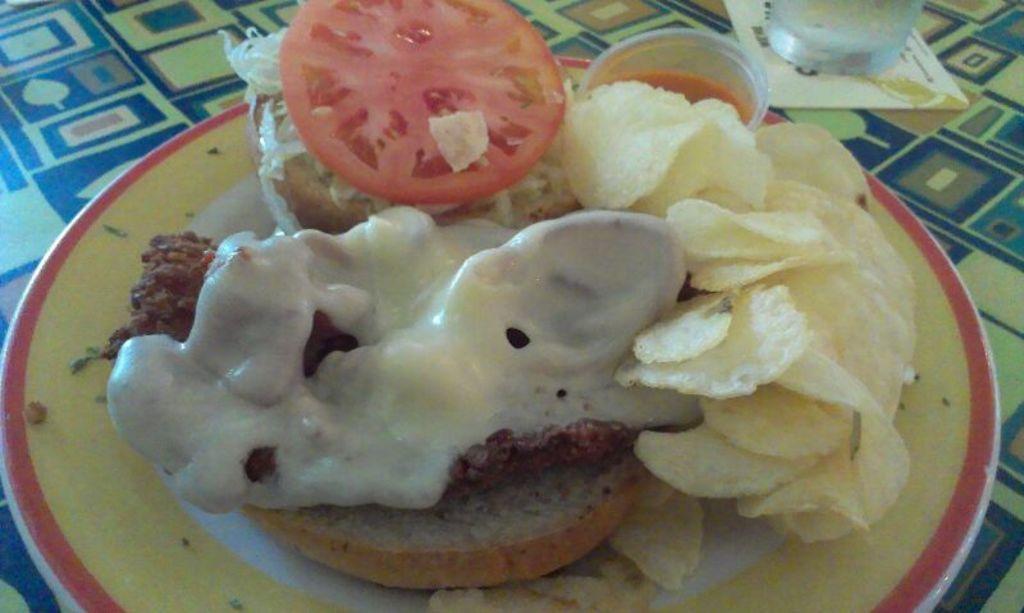Please provide a concise description of this image. In this image there is a table, on that table there is a glass and a plate, in that place there is a food item. 